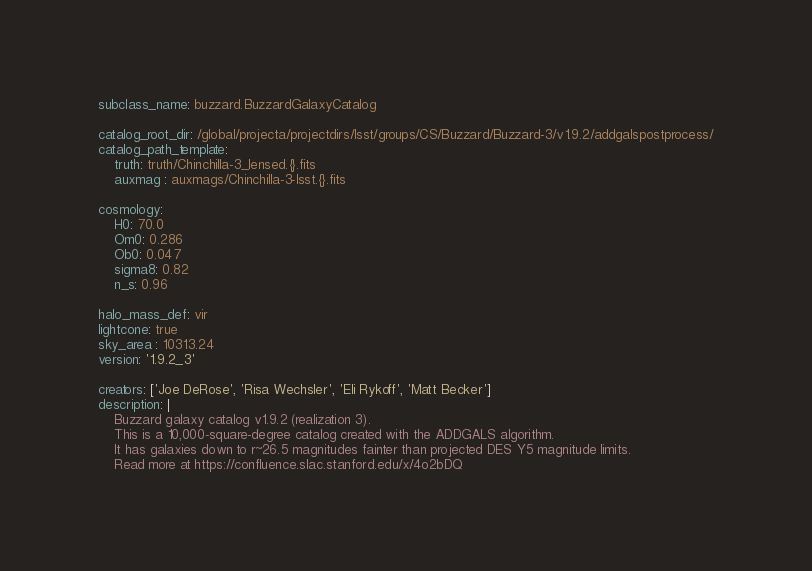<code> <loc_0><loc_0><loc_500><loc_500><_YAML_>subclass_name: buzzard.BuzzardGalaxyCatalog

catalog_root_dir: /global/projecta/projectdirs/lsst/groups/CS/Buzzard/Buzzard-3/v1.9.2/addgalspostprocess/
catalog_path_template:
    truth: truth/Chinchilla-3_lensed.{}.fits
    auxmag : auxmags/Chinchilla-3-lsst.{}.fits

cosmology:
    H0: 70.0
    Om0: 0.286
    Ob0: 0.047
    sigma8: 0.82
    n_s: 0.96

halo_mass_def: vir
lightcone: true
sky_area : 10313.24
version: '1.9.2_3'

creators: ['Joe DeRose', 'Risa Wechsler', 'Eli Rykoff', 'Matt Becker']
description: |
    Buzzard galaxy catalog v1.9.2 (realization 3).
    This is a 10,000-square-degree catalog created with the ADDGALS algorithm.
    It has galaxies down to r~26.5 magnitudes fainter than projected DES Y5 magnitude limits.
    Read more at https://confluence.slac.stanford.edu/x/4o2bDQ
</code> 